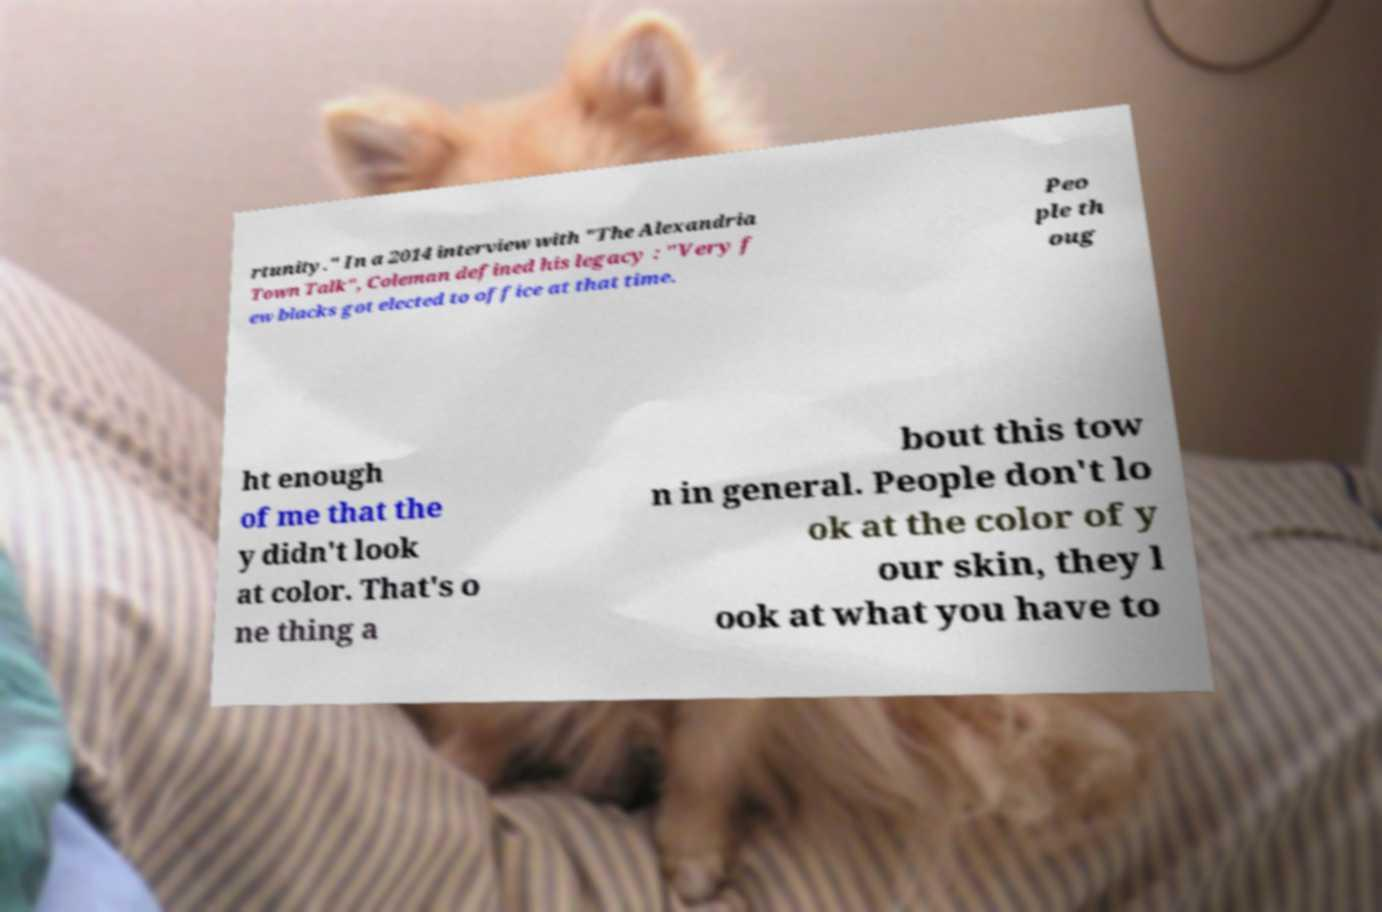Please read and relay the text visible in this image. What does it say? rtunity." In a 2014 interview with "The Alexandria Town Talk", Coleman defined his legacy : "Very f ew blacks got elected to office at that time. Peo ple th oug ht enough of me that the y didn't look at color. That's o ne thing a bout this tow n in general. People don't lo ok at the color of y our skin, they l ook at what you have to 